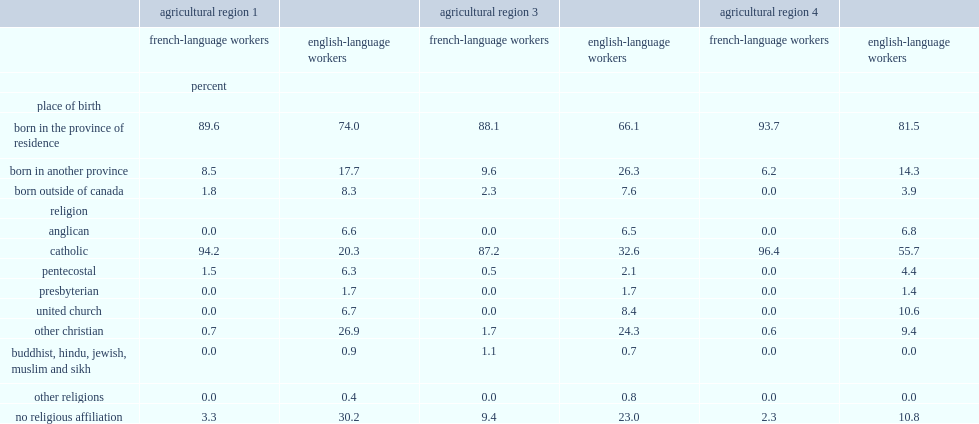In new brunswick's agri-food sector, which sector of workers is the majority of workers who were bron in the province? French-language workers. List the sector of workers that has more than 85% of workers who were born in new brunswick, compared with between 66.1% and 81.5% of english-language workers. French-language workers. Which sector of workers had a lower proportion of workers who were born in another province or country? french-language workers or english-language workers? French-language workers. Which sector of workers had more workers who were catholic in 2011? english-language workers or french-language workers? French-language workers. Which religion is the most popluar religion among all the french-language workers in new brunswick's agir-food sector? Catholic. Which sector of workers were less likely to have declared having no religious affilition? english-language colleagues or french-language workers? French-language workers. 